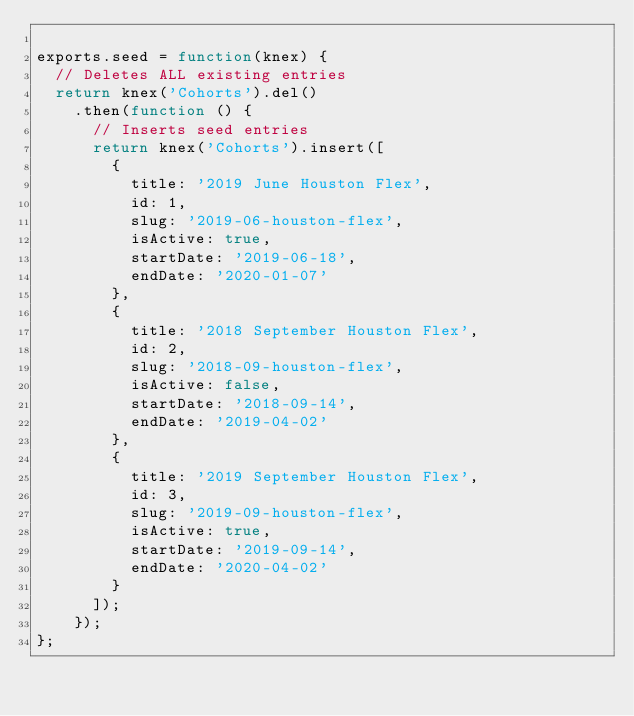<code> <loc_0><loc_0><loc_500><loc_500><_JavaScript_>
exports.seed = function(knex) {
  // Deletes ALL existing entries
  return knex('Cohorts').del()
    .then(function () {
      // Inserts seed entries
      return knex('Cohorts').insert([
        {
          title: '2019 June Houston Flex', 
          id: 1,
          slug: '2019-06-houston-flex', 
          isActive: true, 
          startDate: '2019-06-18', 
          endDate: '2020-01-07'
        },
        {
          title: '2018 September Houston Flex', 
          id: 2,
          slug: '2018-09-houston-flex', 
          isActive: false, 
          startDate: '2018-09-14', 
          endDate: '2019-04-02'
        },
        {
          title: '2019 September Houston Flex', 
          id: 3,
          slug: '2019-09-houston-flex', 
          isActive: true, 
          startDate: '2019-09-14', 
          endDate: '2020-04-02'
        }
      ]);
    });
};
</code> 